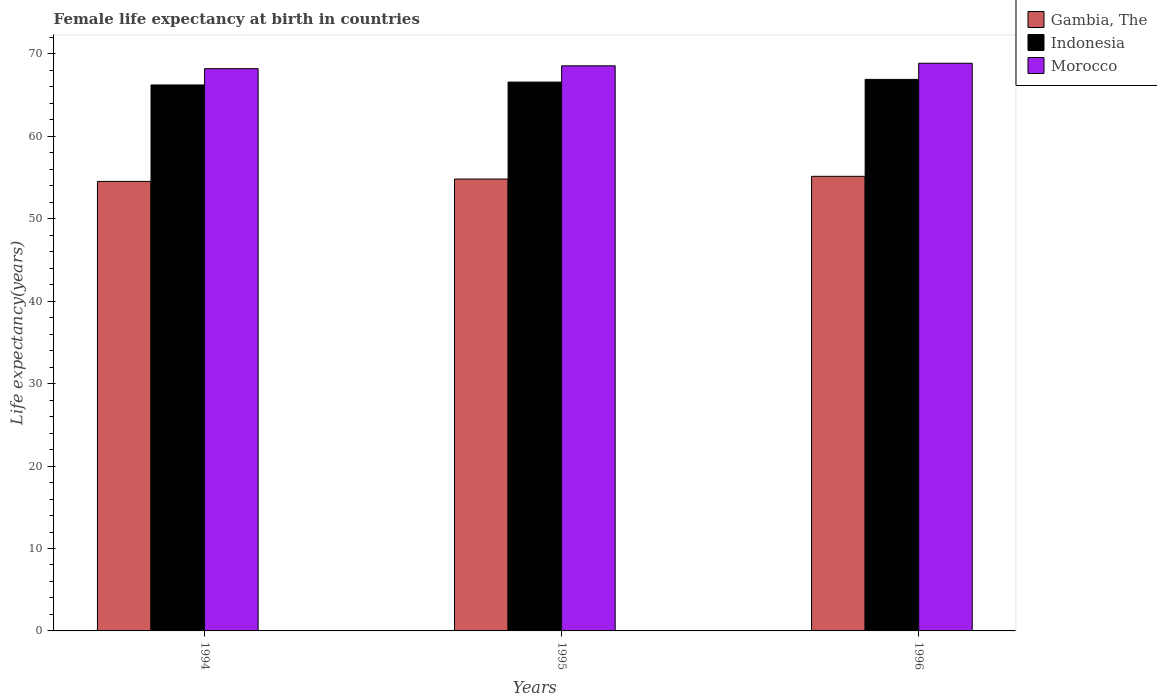How many groups of bars are there?
Give a very brief answer. 3. Are the number of bars on each tick of the X-axis equal?
Provide a short and direct response. Yes. What is the label of the 2nd group of bars from the left?
Your answer should be compact. 1995. In how many cases, is the number of bars for a given year not equal to the number of legend labels?
Your response must be concise. 0. What is the female life expectancy at birth in Gambia, The in 1994?
Ensure brevity in your answer.  54.53. Across all years, what is the maximum female life expectancy at birth in Indonesia?
Provide a succinct answer. 66.91. Across all years, what is the minimum female life expectancy at birth in Indonesia?
Offer a very short reply. 66.23. What is the total female life expectancy at birth in Gambia, The in the graph?
Make the answer very short. 164.51. What is the difference between the female life expectancy at birth in Indonesia in 1995 and that in 1996?
Your answer should be very brief. -0.33. What is the difference between the female life expectancy at birth in Gambia, The in 1994 and the female life expectancy at birth in Morocco in 1995?
Your response must be concise. -14.02. What is the average female life expectancy at birth in Indonesia per year?
Make the answer very short. 66.57. In the year 1995, what is the difference between the female life expectancy at birth in Indonesia and female life expectancy at birth in Morocco?
Offer a very short reply. -1.97. In how many years, is the female life expectancy at birth in Indonesia greater than 18 years?
Give a very brief answer. 3. What is the ratio of the female life expectancy at birth in Morocco in 1994 to that in 1995?
Your answer should be compact. 0.99. Is the female life expectancy at birth in Indonesia in 1994 less than that in 1996?
Give a very brief answer. Yes. What is the difference between the highest and the second highest female life expectancy at birth in Morocco?
Provide a short and direct response. 0.31. What is the difference between the highest and the lowest female life expectancy at birth in Morocco?
Make the answer very short. 0.66. Is the sum of the female life expectancy at birth in Gambia, The in 1994 and 1995 greater than the maximum female life expectancy at birth in Morocco across all years?
Offer a very short reply. Yes. What does the 1st bar from the left in 1995 represents?
Keep it short and to the point. Gambia, The. What does the 1st bar from the right in 1996 represents?
Ensure brevity in your answer.  Morocco. Is it the case that in every year, the sum of the female life expectancy at birth in Gambia, The and female life expectancy at birth in Morocco is greater than the female life expectancy at birth in Indonesia?
Provide a short and direct response. Yes. Are the values on the major ticks of Y-axis written in scientific E-notation?
Your answer should be compact. No. Does the graph contain any zero values?
Offer a terse response. No. Where does the legend appear in the graph?
Give a very brief answer. Top right. How many legend labels are there?
Provide a succinct answer. 3. How are the legend labels stacked?
Make the answer very short. Vertical. What is the title of the graph?
Make the answer very short. Female life expectancy at birth in countries. What is the label or title of the X-axis?
Make the answer very short. Years. What is the label or title of the Y-axis?
Provide a succinct answer. Life expectancy(years). What is the Life expectancy(years) of Gambia, The in 1994?
Your answer should be very brief. 54.53. What is the Life expectancy(years) of Indonesia in 1994?
Provide a succinct answer. 66.23. What is the Life expectancy(years) of Morocco in 1994?
Your answer should be compact. 68.21. What is the Life expectancy(years) in Gambia, The in 1995?
Provide a short and direct response. 54.82. What is the Life expectancy(years) of Indonesia in 1995?
Your answer should be compact. 66.58. What is the Life expectancy(years) in Morocco in 1995?
Offer a terse response. 68.56. What is the Life expectancy(years) in Gambia, The in 1996?
Your response must be concise. 55.15. What is the Life expectancy(years) of Indonesia in 1996?
Your answer should be very brief. 66.91. What is the Life expectancy(years) in Morocco in 1996?
Offer a terse response. 68.87. Across all years, what is the maximum Life expectancy(years) of Gambia, The?
Provide a short and direct response. 55.15. Across all years, what is the maximum Life expectancy(years) in Indonesia?
Make the answer very short. 66.91. Across all years, what is the maximum Life expectancy(years) in Morocco?
Your answer should be very brief. 68.87. Across all years, what is the minimum Life expectancy(years) in Gambia, The?
Your answer should be very brief. 54.53. Across all years, what is the minimum Life expectancy(years) of Indonesia?
Make the answer very short. 66.23. Across all years, what is the minimum Life expectancy(years) in Morocco?
Provide a short and direct response. 68.21. What is the total Life expectancy(years) of Gambia, The in the graph?
Your response must be concise. 164.51. What is the total Life expectancy(years) of Indonesia in the graph?
Give a very brief answer. 199.72. What is the total Life expectancy(years) of Morocco in the graph?
Ensure brevity in your answer.  205.63. What is the difference between the Life expectancy(years) of Gambia, The in 1994 and that in 1995?
Make the answer very short. -0.29. What is the difference between the Life expectancy(years) of Indonesia in 1994 and that in 1995?
Keep it short and to the point. -0.35. What is the difference between the Life expectancy(years) of Morocco in 1994 and that in 1995?
Provide a succinct answer. -0.34. What is the difference between the Life expectancy(years) of Gambia, The in 1994 and that in 1996?
Your response must be concise. -0.61. What is the difference between the Life expectancy(years) in Indonesia in 1994 and that in 1996?
Offer a very short reply. -0.68. What is the difference between the Life expectancy(years) of Morocco in 1994 and that in 1996?
Make the answer very short. -0.66. What is the difference between the Life expectancy(years) in Gambia, The in 1995 and that in 1996?
Your response must be concise. -0.33. What is the difference between the Life expectancy(years) in Indonesia in 1995 and that in 1996?
Your response must be concise. -0.33. What is the difference between the Life expectancy(years) of Morocco in 1995 and that in 1996?
Make the answer very short. -0.31. What is the difference between the Life expectancy(years) in Gambia, The in 1994 and the Life expectancy(years) in Indonesia in 1995?
Make the answer very short. -12.05. What is the difference between the Life expectancy(years) of Gambia, The in 1994 and the Life expectancy(years) of Morocco in 1995?
Keep it short and to the point. -14.02. What is the difference between the Life expectancy(years) in Indonesia in 1994 and the Life expectancy(years) in Morocco in 1995?
Offer a terse response. -2.32. What is the difference between the Life expectancy(years) of Gambia, The in 1994 and the Life expectancy(years) of Indonesia in 1996?
Provide a succinct answer. -12.37. What is the difference between the Life expectancy(years) of Gambia, The in 1994 and the Life expectancy(years) of Morocco in 1996?
Offer a very short reply. -14.33. What is the difference between the Life expectancy(years) in Indonesia in 1994 and the Life expectancy(years) in Morocco in 1996?
Your answer should be compact. -2.63. What is the difference between the Life expectancy(years) in Gambia, The in 1995 and the Life expectancy(years) in Indonesia in 1996?
Make the answer very short. -12.09. What is the difference between the Life expectancy(years) of Gambia, The in 1995 and the Life expectancy(years) of Morocco in 1996?
Give a very brief answer. -14.04. What is the difference between the Life expectancy(years) of Indonesia in 1995 and the Life expectancy(years) of Morocco in 1996?
Your response must be concise. -2.29. What is the average Life expectancy(years) of Gambia, The per year?
Your answer should be compact. 54.84. What is the average Life expectancy(years) of Indonesia per year?
Your response must be concise. 66.58. What is the average Life expectancy(years) in Morocco per year?
Offer a very short reply. 68.55. In the year 1994, what is the difference between the Life expectancy(years) in Gambia, The and Life expectancy(years) in Indonesia?
Make the answer very short. -11.7. In the year 1994, what is the difference between the Life expectancy(years) of Gambia, The and Life expectancy(years) of Morocco?
Provide a succinct answer. -13.68. In the year 1994, what is the difference between the Life expectancy(years) of Indonesia and Life expectancy(years) of Morocco?
Make the answer very short. -1.98. In the year 1995, what is the difference between the Life expectancy(years) of Gambia, The and Life expectancy(years) of Indonesia?
Give a very brief answer. -11.76. In the year 1995, what is the difference between the Life expectancy(years) in Gambia, The and Life expectancy(years) in Morocco?
Your answer should be compact. -13.73. In the year 1995, what is the difference between the Life expectancy(years) in Indonesia and Life expectancy(years) in Morocco?
Your response must be concise. -1.97. In the year 1996, what is the difference between the Life expectancy(years) in Gambia, The and Life expectancy(years) in Indonesia?
Offer a very short reply. -11.76. In the year 1996, what is the difference between the Life expectancy(years) in Gambia, The and Life expectancy(years) in Morocco?
Keep it short and to the point. -13.72. In the year 1996, what is the difference between the Life expectancy(years) of Indonesia and Life expectancy(years) of Morocco?
Give a very brief answer. -1.96. What is the ratio of the Life expectancy(years) in Gambia, The in 1994 to that in 1995?
Your response must be concise. 0.99. What is the ratio of the Life expectancy(years) in Morocco in 1994 to that in 1995?
Make the answer very short. 0.99. What is the ratio of the Life expectancy(years) of Gambia, The in 1994 to that in 1996?
Make the answer very short. 0.99. What is the ratio of the Life expectancy(years) of Morocco in 1994 to that in 1996?
Your answer should be very brief. 0.99. What is the ratio of the Life expectancy(years) of Indonesia in 1995 to that in 1996?
Offer a terse response. 1. What is the difference between the highest and the second highest Life expectancy(years) in Gambia, The?
Keep it short and to the point. 0.33. What is the difference between the highest and the second highest Life expectancy(years) of Indonesia?
Keep it short and to the point. 0.33. What is the difference between the highest and the second highest Life expectancy(years) of Morocco?
Your response must be concise. 0.31. What is the difference between the highest and the lowest Life expectancy(years) of Gambia, The?
Keep it short and to the point. 0.61. What is the difference between the highest and the lowest Life expectancy(years) in Indonesia?
Provide a short and direct response. 0.68. What is the difference between the highest and the lowest Life expectancy(years) of Morocco?
Your answer should be very brief. 0.66. 